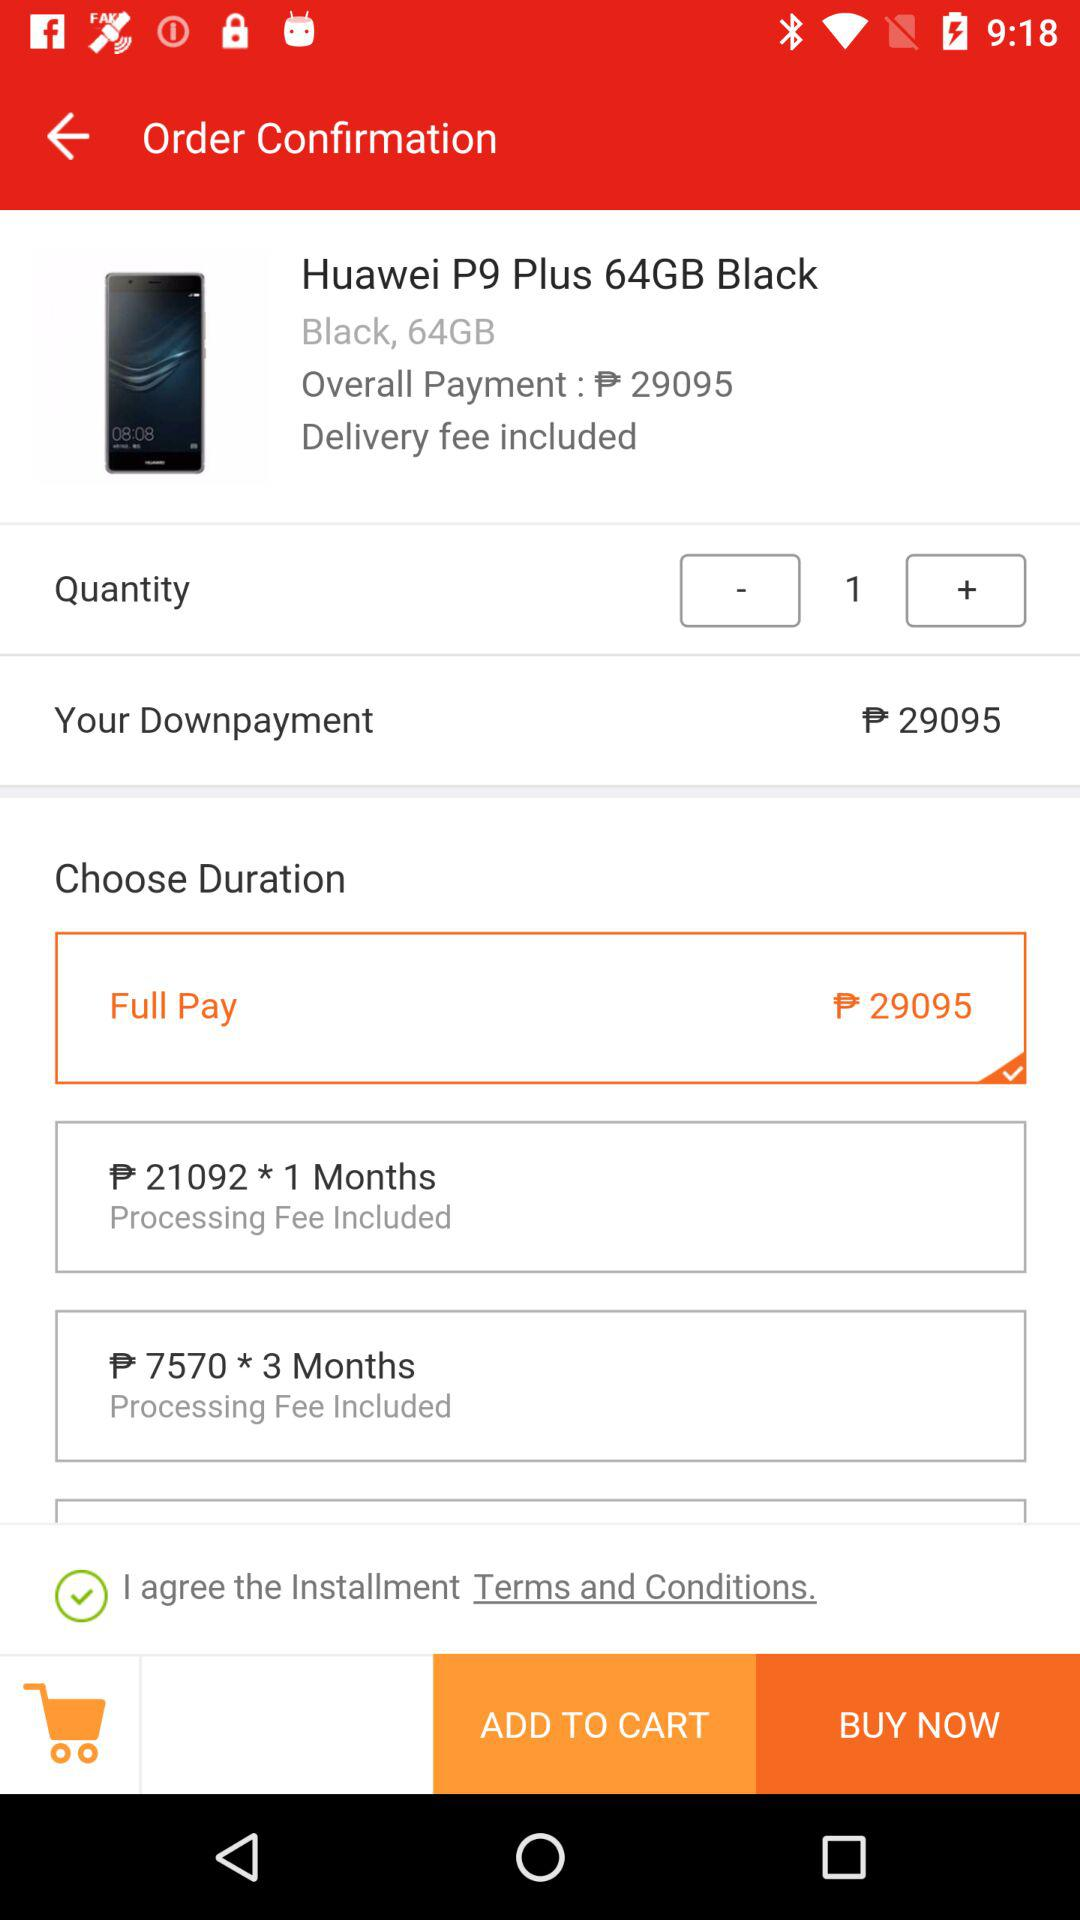What is the colour of the Huawei P9 Plus? The colour is "Black". 